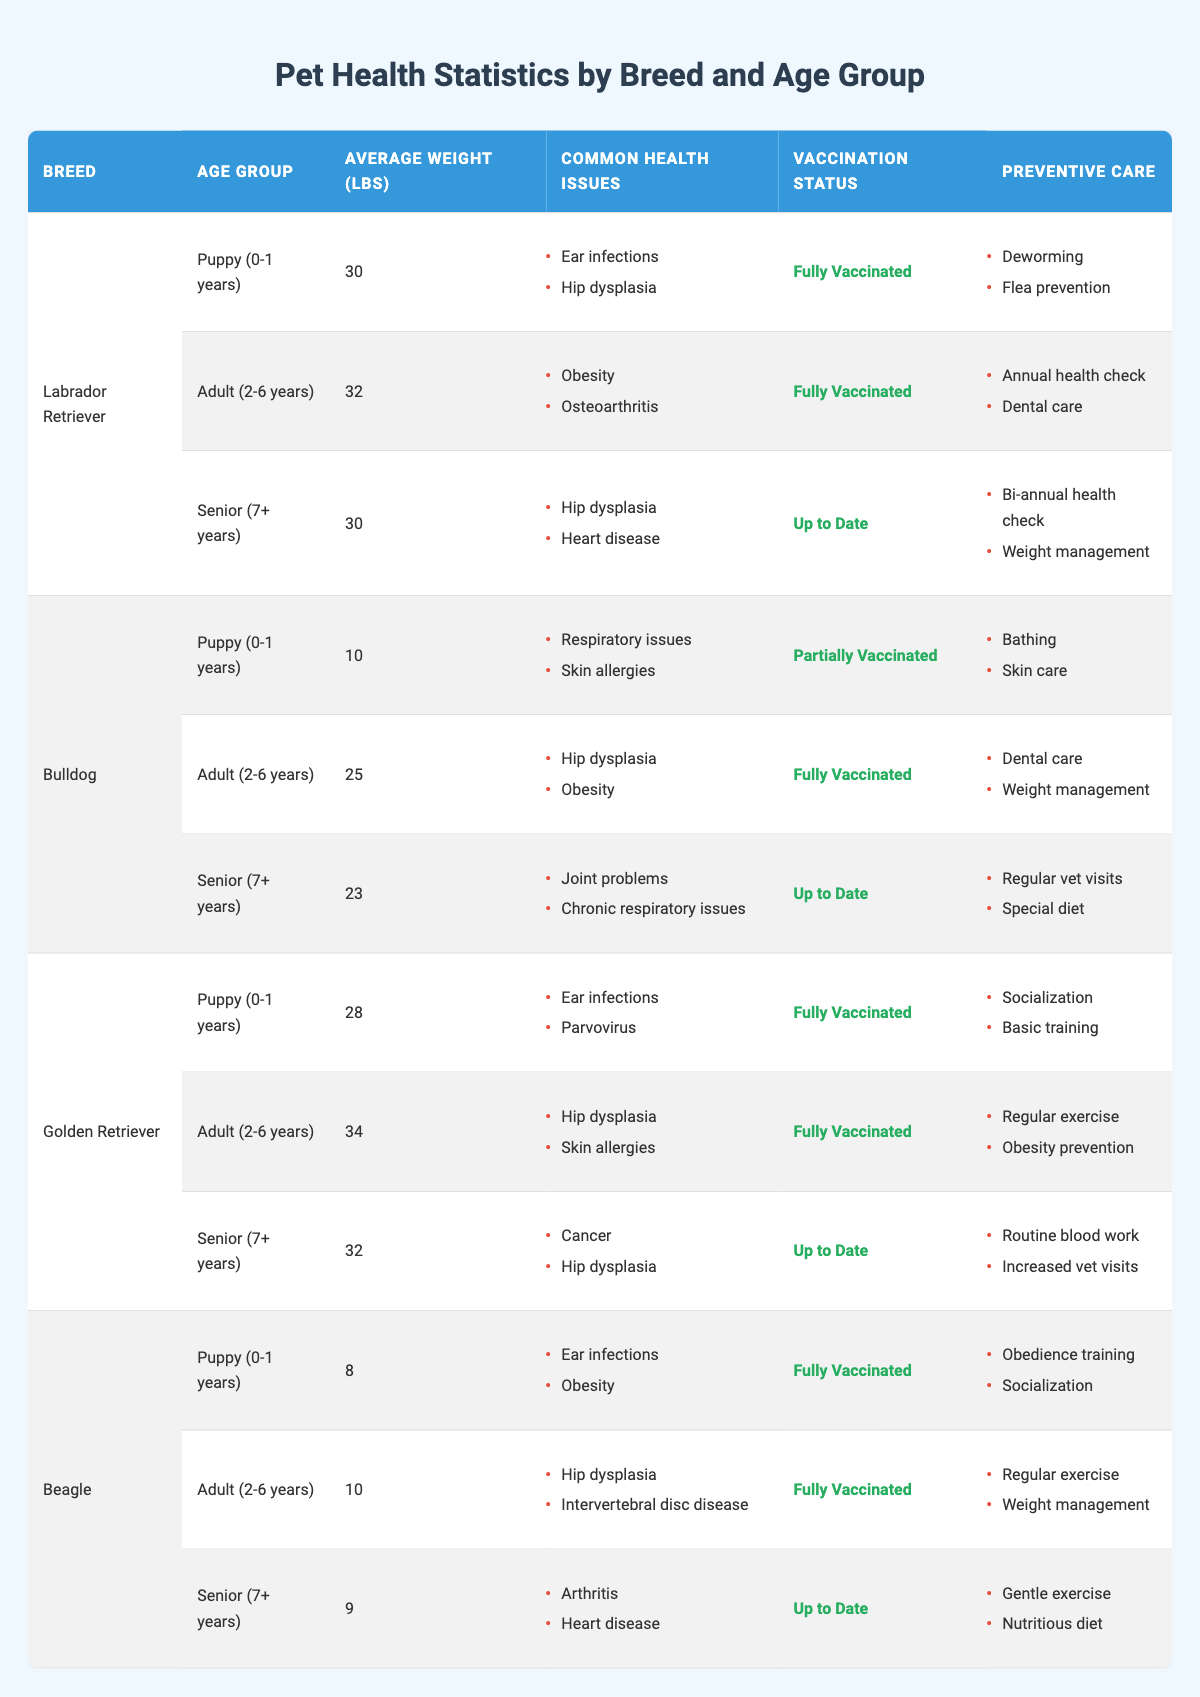What is the average weight of a Bulldog in the Adult age group? From the table, the average weight listed for Bulldogs in the Adult (2-6 years) category is 25 lbs.
Answer: 25 lbs Which breed has the highest average weight as a Senior? Looking through the table, the Golden Retriever has an average weight of 32 lbs in the Senior (7+ years) category, which is higher than the average weights for Senior Bulldogs (23 lbs) and Beagles (9 lbs).
Answer: Golden Retriever Does the Labrador Retriever breed have any Senior health issues related to heart disease? Yes, the table specifies that Senior Labrador Retrievers commonly experience heart disease as a health issue.
Answer: Yes What is the common health issue for Beagles in their Puppy stage? According to the table, Beagle puppies have common health issues of ear infections and obesity.
Answer: Ear infections and obesity In terms of preventive care, how does the care for an Adult Beagle differ from that of an Adult Bulldog? For Adult Beagles, the preventive care includes regular exercise and weight management, while for Adult Bulldogs, the preventive care involves dental care and weight management.
Answer: Different care involves regular exercise for Beagles and dental care for Bulldogs Which breed has the most common health issues documented, and what are those issues? The Golden Retriever has documented common health issues of ear infections and parvovirus in puppies, hip dysplasia and skin allergies in adults, and cancer and hip dysplasia in seniors, making them have three different documented issues though not necessarily the most overall.
Answer: Golden Retriever; ear infections, parvovirus, hip dysplasia, skin allergies, cancer Is it true that all puppies listed in the table are fully vaccinated? A review of the table reveals that both Labrador Retrievers, Golden Retrievers, and Beagles are all indicated as fully vaccinated in the Puppy (0-1 years) category. However, Bulldogs in the same category are partially vaccinated.
Answer: No Which age group for Labrador Retrievers experiences the highest common health issues, and what are they? The Senior age group for Labrador Retrievers shows common health issues of hip dysplasia and heart disease.
Answer: Senior age group; hip dysplasia, heart disease How many breeds listed have a preventive care item related to “weight management”? Based on the table, weight management is mentioned in the preventive care for Adult Bulldogs, Adult Beagles, and Senior Labradors, making it three breeds in total that focus on weight management.
Answer: Three breeds What are the average weights of the Beagle across all age groups? By reviewing the table, the average weights of Beagle puppies, adults, and seniors are 8 lbs, 10 lbs, and 9 lbs respectively. Thus, the average weight across these three groups is (8+10+9)/3 = 9 lbs.
Answer: 9 lbs Which breed has the least average weight in the Puppy age group? The table shows that Beagle puppies have the least average weight at 8 lbs compared to Labrador and Bulldog puppies, which weigh 30 lbs and 10 lbs respectively.
Answer: Beagle 